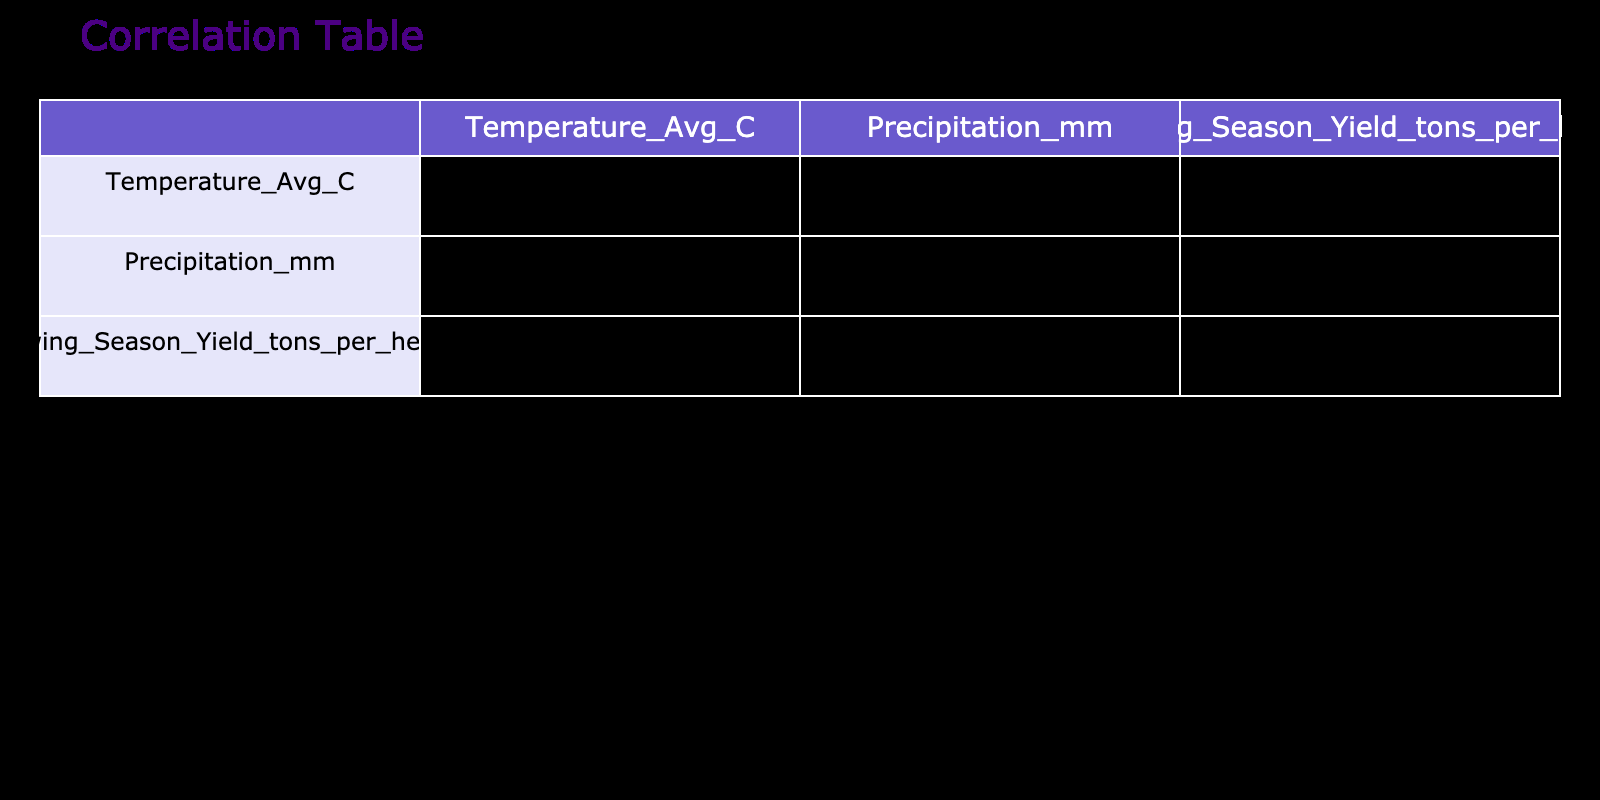What is the correlation coefficient between average temperature and agricultural yield? From the correlation table, the correlation coefficient value listed in the row for Temperature_Avg_C and the column for Growing_Season_Yield_tons_per_hectare is 0.87. This indicates a strong positive correlation between average temperature and agricultural yield.
Answer: 0.87 What is the correlation coefficient between precipitation and agricultural yield? The value in the row for Precipitation_mm and the column for Growing_Season_Yield_tons_per_hectare shows a correlation coefficient of -0.65. This negative value suggests that as precipitation increases, agricultural yield tends to decrease.
Answer: -0.65 Is there a significant positive correlation between average temperature and precipitation? The correlation coefficient between Temperature_Avg_C and Precipitation_mm is -0.38, indicating that there is no significant positive correlation based on the values shown in the table.
Answer: No Which crop type tends to yield the highest amount per hectare based on the correlation data? The crop type that has the highest yield per hectare across all years is Almonds, with values reaching up to 8.0 tons per hectare in the year 2022. Analyzing the agricultural yield values across all crop types confirms this trend.
Answer: Almonds What is the average agricultural yield for Maize over the years included in the table? To find the average yield for Maize, we take the values 4.5, 5.0, 4.8, 5.2, 6.0, and 5.5, which sum up to 31.0. Divide that by 6 (the number of years), resulting in an average yield of 5.17 tons per hectare for Maize.
Answer: 5.17 Which year exhibited the highest correlation between average temperature and agricultural yield? By examining the correlation values in the table, we observe that 2022 has the highest value of 0.91, indicating the strongest correlation for that year between average temperature and agricultural yield.
Answer: 2022 Is it true that Kansas had a lower yield than Iowa in 2021? Looking at the values in the table, Kansas had a yield of 4.5 tons per hectare while Iowa had a yield of 5.2 tons per hectare in 2021. Since 4.5 is less than 5.2, the statement is true.
Answer: Yes What is the difference in yield between the highest and lowest yielding crop types? The highest yielding crop type is Almonds with 8.0 tons per hectare in 2022, while the lowest is Wheat with 3.8 tons per hectare in 2018. The difference between these yields is 8.0 - 3.8 = 4.2 tons per hectare.
Answer: 4.2 What was the trend of average temperatures over the years? By observing the average temperature values for each year (15.2, 14.5, 16.0, 15.5, 17.0, 15.8), we find that temperatures generally increased from 2018 through 2022, before slightly decreasing in 2023 to 15.8. Thus, the general trend shows temperatures rising with minor fluctuations.
Answer: Rising with fluctuations 